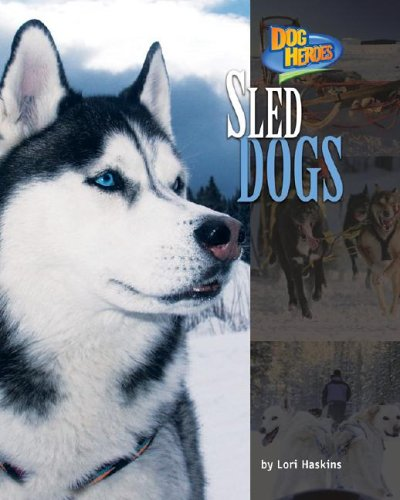What is the title of this book? The book's title is 'Sled Dogs (Dog Heroes)', indicating a focus on the role of sled dogs and their remarkable contributions. 